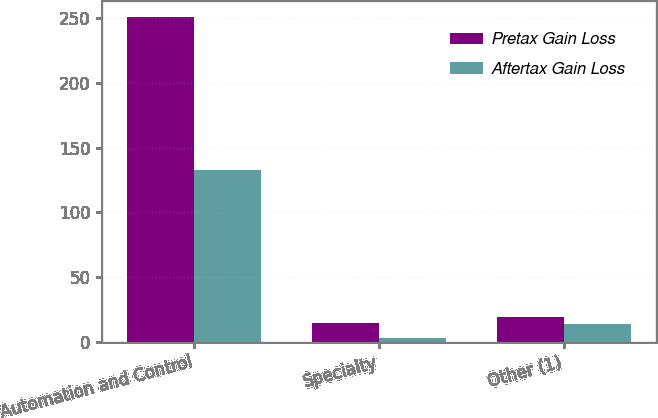<chart> <loc_0><loc_0><loc_500><loc_500><stacked_bar_chart><ecel><fcel>Automation and Control<fcel>Specialty<fcel>Other (1)<nl><fcel>Pretax Gain Loss<fcel>251<fcel>15<fcel>19<nl><fcel>Aftertax Gain Loss<fcel>133<fcel>3<fcel>14<nl></chart> 